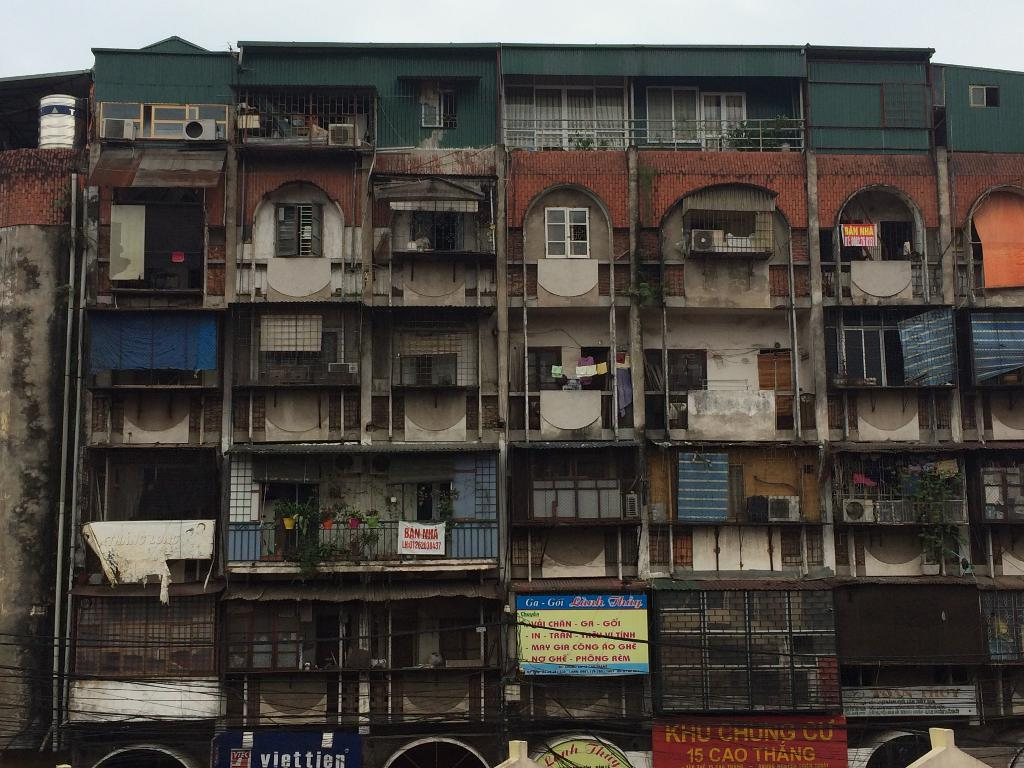What type of structure is present in the image? There is a building in the image. What feature can be seen on the building? The building has windows. What else is present in the image besides the building? There are plants, hoardings, and banners in the image. What is the purpose of the grill on the building? The building has a grill, which might serve as a security feature or for ventilation. What can be seen in the sky in the image? The sky is visible in the image. What time of day is it in the image, and is the government represented in any way? The time of day cannot be determined from the image, and there is no indication of government representation in the image. Can you see a bat flying in the image? There is no bat present in the image. 